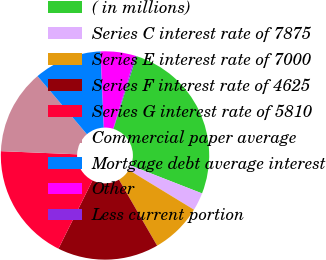Convert chart to OTSL. <chart><loc_0><loc_0><loc_500><loc_500><pie_chart><fcel>( in millions)<fcel>Series C interest rate of 7875<fcel>Series E interest rate of 7000<fcel>Series F interest rate of 4625<fcel>Series G interest rate of 5810<fcel>Commercial paper average<fcel>Mortgage debt average interest<fcel>Other<fcel>Less current portion<nl><fcel>26.05%<fcel>2.78%<fcel>7.95%<fcel>15.71%<fcel>18.29%<fcel>13.12%<fcel>10.54%<fcel>5.37%<fcel>0.19%<nl></chart> 